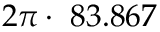<formula> <loc_0><loc_0><loc_500><loc_500>2 \pi \cdot 8 3 . 8 6 7</formula> 